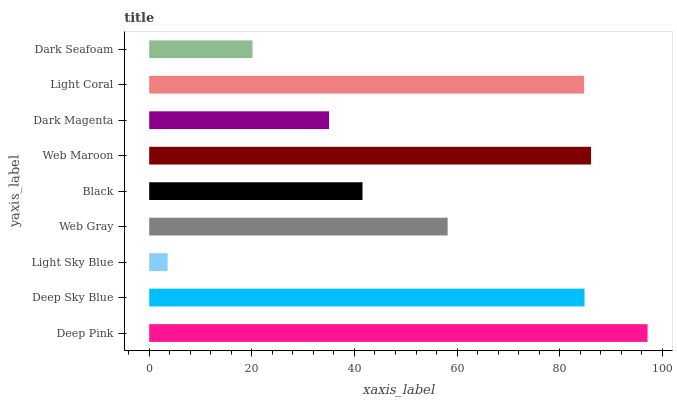Is Light Sky Blue the minimum?
Answer yes or no. Yes. Is Deep Pink the maximum?
Answer yes or no. Yes. Is Deep Sky Blue the minimum?
Answer yes or no. No. Is Deep Sky Blue the maximum?
Answer yes or no. No. Is Deep Pink greater than Deep Sky Blue?
Answer yes or no. Yes. Is Deep Sky Blue less than Deep Pink?
Answer yes or no. Yes. Is Deep Sky Blue greater than Deep Pink?
Answer yes or no. No. Is Deep Pink less than Deep Sky Blue?
Answer yes or no. No. Is Web Gray the high median?
Answer yes or no. Yes. Is Web Gray the low median?
Answer yes or no. Yes. Is Light Sky Blue the high median?
Answer yes or no. No. Is Light Coral the low median?
Answer yes or no. No. 